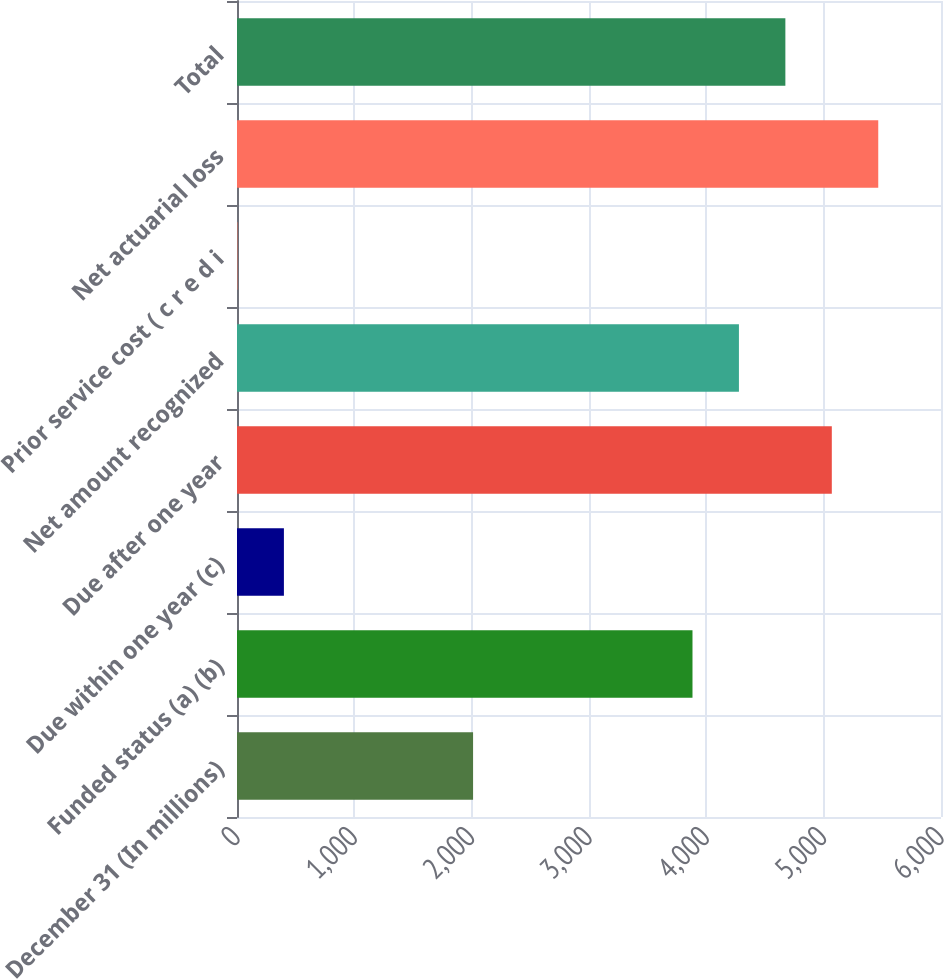<chart> <loc_0><loc_0><loc_500><loc_500><bar_chart><fcel>December 31 (In millions)<fcel>Funded status (a) (b)<fcel>Due within one year (c)<fcel>Due after one year<fcel>Net amount recognized<fcel>Prior service cost ( c r e d i<fcel>Net actuarial loss<fcel>Total<nl><fcel>2012<fcel>3882<fcel>399.8<fcel>5069.4<fcel>4277.8<fcel>4<fcel>5465.2<fcel>4673.6<nl></chart> 